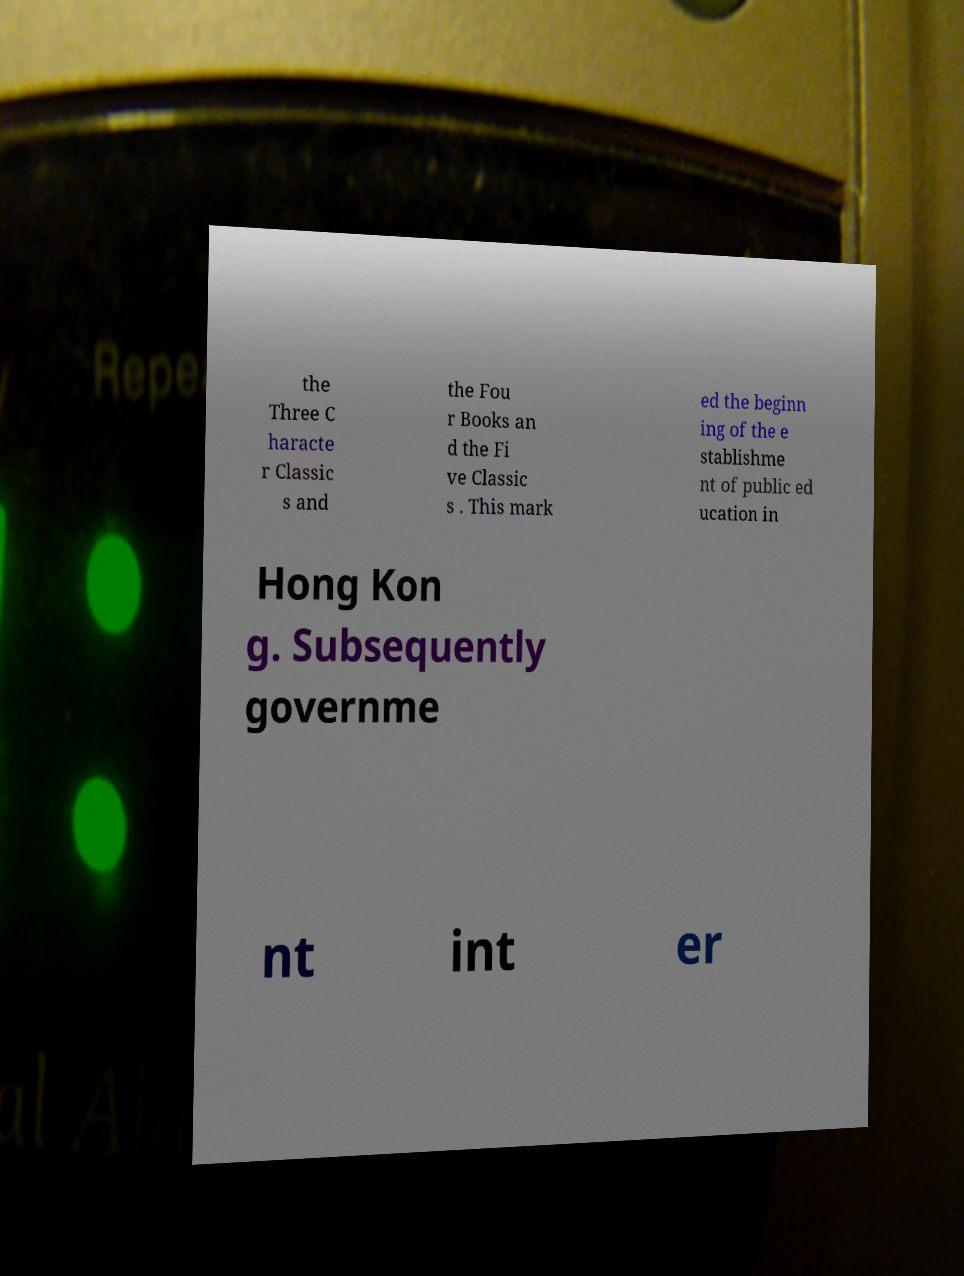There's text embedded in this image that I need extracted. Can you transcribe it verbatim? the Three C haracte r Classic s and the Fou r Books an d the Fi ve Classic s . This mark ed the beginn ing of the e stablishme nt of public ed ucation in Hong Kon g. Subsequently governme nt int er 